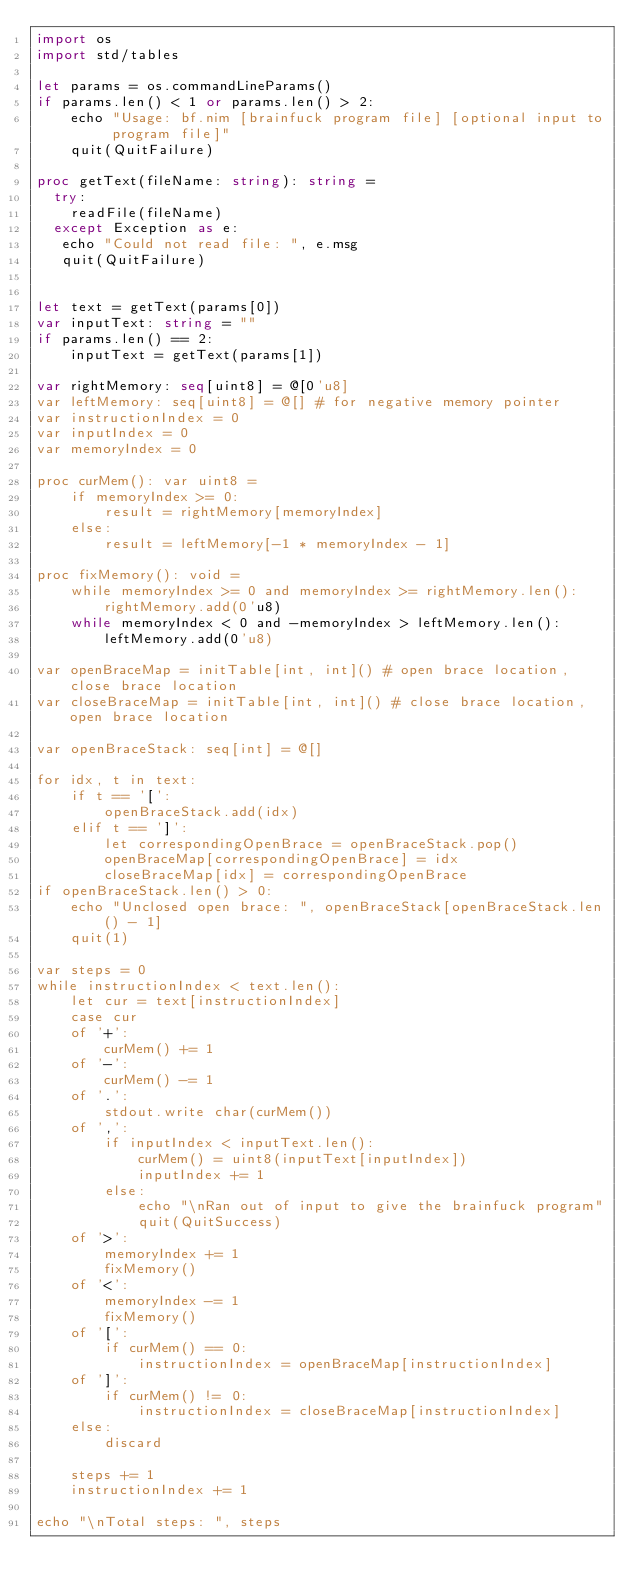Convert code to text. <code><loc_0><loc_0><loc_500><loc_500><_Nim_>import os
import std/tables

let params = os.commandLineParams()
if params.len() < 1 or params.len() > 2:
    echo "Usage: bf.nim [brainfuck program file] [optional input to program file]"
    quit(QuitFailure)

proc getText(fileName: string): string =
  try:
    readFile(fileName)
  except Exception as e:
   echo "Could not read file: ", e.msg
   quit(QuitFailure)
        

let text = getText(params[0])
var inputText: string = ""
if params.len() == 2:
    inputText = getText(params[1])

var rightMemory: seq[uint8] = @[0'u8]
var leftMemory: seq[uint8] = @[] # for negative memory pointer
var instructionIndex = 0
var inputIndex = 0
var memoryIndex = 0

proc curMem(): var uint8 =
    if memoryIndex >= 0:
        result = rightMemory[memoryIndex]
    else:
        result = leftMemory[-1 * memoryIndex - 1]

proc fixMemory(): void =
    while memoryIndex >= 0 and memoryIndex >= rightMemory.len():
        rightMemory.add(0'u8)
    while memoryIndex < 0 and -memoryIndex > leftMemory.len():
        leftMemory.add(0'u8)

var openBraceMap = initTable[int, int]() # open brace location, close brace location
var closeBraceMap = initTable[int, int]() # close brace location, open brace location

var openBraceStack: seq[int] = @[]

for idx, t in text:
    if t == '[':
        openBraceStack.add(idx)
    elif t == ']':
        let correspondingOpenBrace = openBraceStack.pop()
        openBraceMap[correspondingOpenBrace] = idx
        closeBraceMap[idx] = correspondingOpenBrace
if openBraceStack.len() > 0:
    echo "Unclosed open brace: ", openBraceStack[openBraceStack.len() - 1]
    quit(1)

var steps = 0
while instructionIndex < text.len():
    let cur = text[instructionIndex] 
    case cur
    of '+':
        curMem() += 1
    of '-':
        curMem() -= 1
    of '.':
        stdout.write char(curMem())
    of ',':
        if inputIndex < inputText.len():
            curMem() = uint8(inputText[inputIndex])
            inputIndex += 1
        else:
            echo "\nRan out of input to give the brainfuck program"
            quit(QuitSuccess)
    of '>':
        memoryIndex += 1
        fixMemory()
    of '<':
        memoryIndex -= 1
        fixMemory()
    of '[':
        if curMem() == 0:
            instructionIndex = openBraceMap[instructionIndex]
    of ']':
        if curMem() != 0:
            instructionIndex = closeBraceMap[instructionIndex]
    else:
        discard
    
    steps += 1
    instructionIndex += 1

echo "\nTotal steps: ", steps</code> 